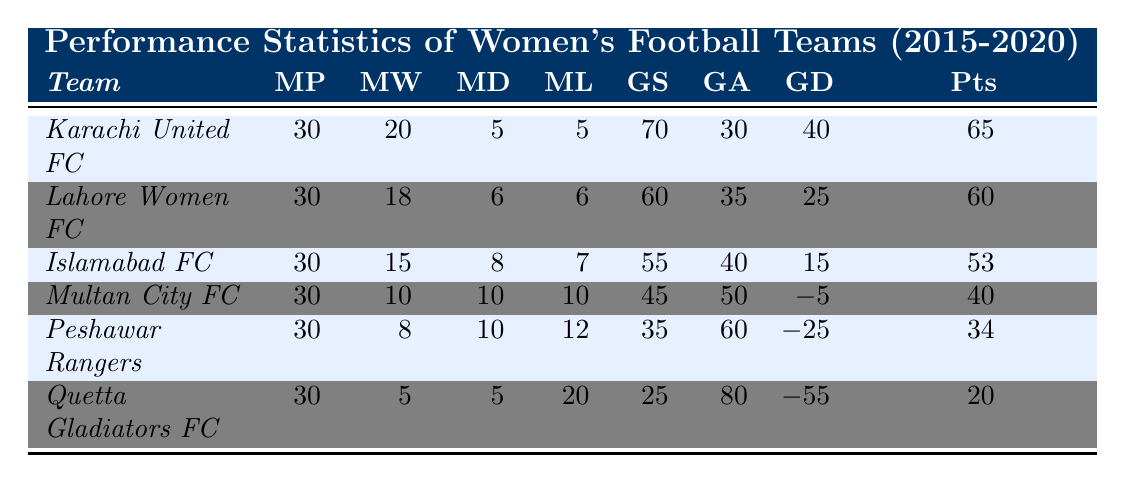What is the team with the highest number of matches won? Karachi United FC has the highest number of matches won with 20 wins.
Answer: Karachi United FC How many goals did Peshawar Rangers score during the championship? Peshawar Rangers scored a total of 35 goals in the championship, as noted in the goals scored column.
Answer: 35 What is the goal difference for Lahore Women FC? Lahore Women FC has a goal difference of 25, calculated by subtracting goals against (35) from goals scored (60).
Answer: 25 Which team had the lowest points? Quetta Gladiators FC had the lowest points, with a total of 20 points.
Answer: Quetta Gladiators FC What is the average number of matches won by all teams? The total matches won by all teams is (20 + 18 + 15 + 10 + 8 + 5) = 76, and there are 6 teams, so the average is 76/6 = 12.67.
Answer: 12.67 Did any team not win any matches? Yes, Quetta Gladiators FC did not win any matches, as indicated by its 5 draws and 20 losses.
Answer: Yes Which team had the highest goals scored but not the most points? Lahore Women FC scored 60 goals but had fewer points (60) than Karachi United FC (65), which scored more goals (70).
Answer: Lahore Women FC What is the total number of matches played by all teams combined? Each team played 30 matches, and there are 6 teams, so the total matches played is 30 * 6 = 180.
Answer: 180 Which team had the best goal difference? Karachi United FC had the best goal difference of 40, calculated as goals scored (70) minus goals against (30).
Answer: Karachi United FC How many teams had a negative goal difference? Two teams, Multan City FC and Peshawar Rangers, had negative goal differences (-5 and -25, respectively).
Answer: 2 What is the total number of matches drawn across all teams? The total matches drawn are (5 + 6 + 8 + 10 + 10 + 5) = 44 drawn matches across all teams.
Answer: 44 